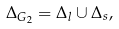<formula> <loc_0><loc_0><loc_500><loc_500>\Delta _ { G _ { 2 } } = \Delta _ { l } \cup \Delta _ { s } ,</formula> 